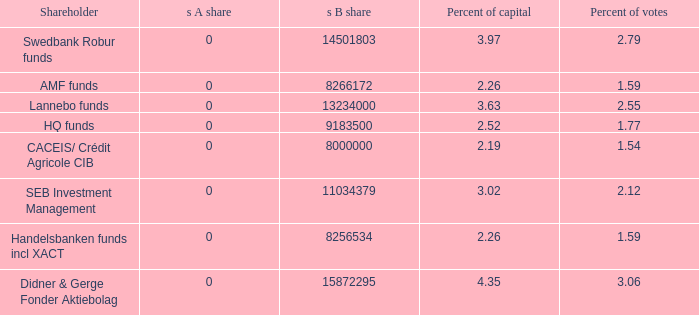What is the s B share for the shareholder that has 2.55 percent of votes?  13234000.0. Could you parse the entire table as a dict? {'header': ['Shareholder', 's A share', 's B share', 'Percent of capital', 'Percent of votes'], 'rows': [['Swedbank Robur funds', '0', '14501803', '3.97', '2.79'], ['AMF funds', '0', '8266172', '2.26', '1.59'], ['Lannebo funds', '0', '13234000', '3.63', '2.55'], ['HQ funds', '0', '9183500', '2.52', '1.77'], ['CACEIS/ Crédit Agricole CIB', '0', '8000000', '2.19', '1.54'], ['SEB Investment Management', '0', '11034379', '3.02', '2.12'], ['Handelsbanken funds incl XACT', '0', '8256534', '2.26', '1.59'], ['Didner & Gerge Fonder Aktiebolag', '0', '15872295', '4.35', '3.06']]} 